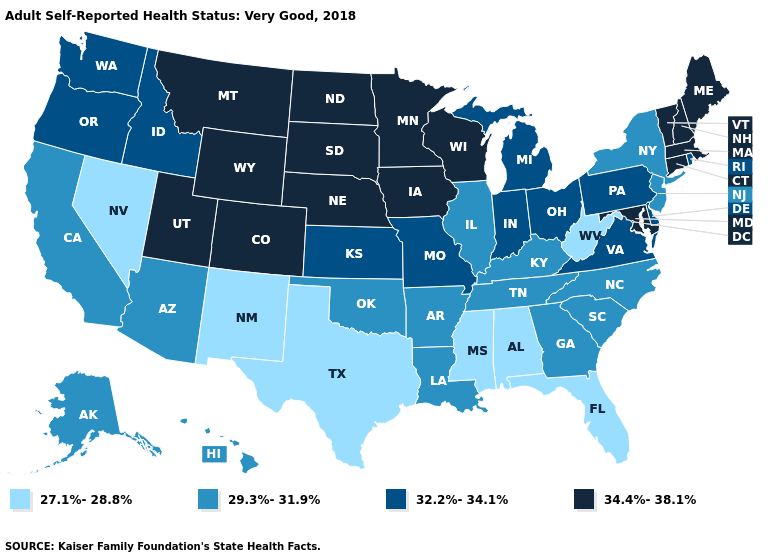Does Minnesota have the same value as New Jersey?
Concise answer only. No. Name the states that have a value in the range 29.3%-31.9%?
Write a very short answer. Alaska, Arizona, Arkansas, California, Georgia, Hawaii, Illinois, Kentucky, Louisiana, New Jersey, New York, North Carolina, Oklahoma, South Carolina, Tennessee. What is the value of Utah?
Concise answer only. 34.4%-38.1%. Among the states that border Maryland , which have the highest value?
Short answer required. Delaware, Pennsylvania, Virginia. What is the highest value in the USA?
Short answer required. 34.4%-38.1%. Name the states that have a value in the range 29.3%-31.9%?
Write a very short answer. Alaska, Arizona, Arkansas, California, Georgia, Hawaii, Illinois, Kentucky, Louisiana, New Jersey, New York, North Carolina, Oklahoma, South Carolina, Tennessee. What is the value of New Mexico?
Concise answer only. 27.1%-28.8%. What is the lowest value in the USA?
Quick response, please. 27.1%-28.8%. Does the first symbol in the legend represent the smallest category?
Concise answer only. Yes. What is the value of Rhode Island?
Keep it brief. 32.2%-34.1%. Which states have the lowest value in the MidWest?
Quick response, please. Illinois. Name the states that have a value in the range 32.2%-34.1%?
Concise answer only. Delaware, Idaho, Indiana, Kansas, Michigan, Missouri, Ohio, Oregon, Pennsylvania, Rhode Island, Virginia, Washington. Which states have the lowest value in the Northeast?
Be succinct. New Jersey, New York. Name the states that have a value in the range 34.4%-38.1%?
Be succinct. Colorado, Connecticut, Iowa, Maine, Maryland, Massachusetts, Minnesota, Montana, Nebraska, New Hampshire, North Dakota, South Dakota, Utah, Vermont, Wisconsin, Wyoming. What is the value of Arizona?
Answer briefly. 29.3%-31.9%. 